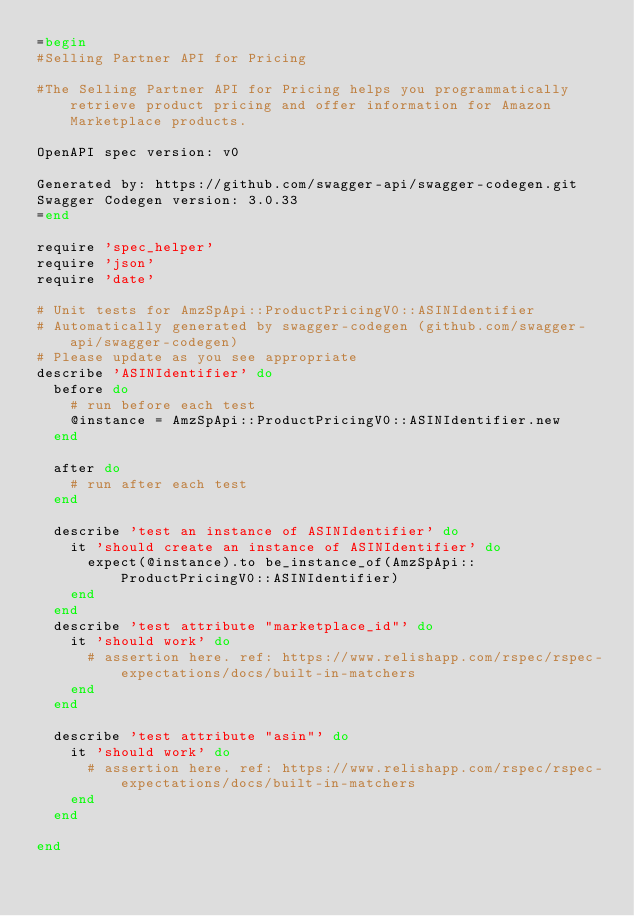<code> <loc_0><loc_0><loc_500><loc_500><_Ruby_>=begin
#Selling Partner API for Pricing

#The Selling Partner API for Pricing helps you programmatically retrieve product pricing and offer information for Amazon Marketplace products.

OpenAPI spec version: v0

Generated by: https://github.com/swagger-api/swagger-codegen.git
Swagger Codegen version: 3.0.33
=end

require 'spec_helper'
require 'json'
require 'date'

# Unit tests for AmzSpApi::ProductPricingV0::ASINIdentifier
# Automatically generated by swagger-codegen (github.com/swagger-api/swagger-codegen)
# Please update as you see appropriate
describe 'ASINIdentifier' do
  before do
    # run before each test
    @instance = AmzSpApi::ProductPricingV0::ASINIdentifier.new
  end

  after do
    # run after each test
  end

  describe 'test an instance of ASINIdentifier' do
    it 'should create an instance of ASINIdentifier' do
      expect(@instance).to be_instance_of(AmzSpApi::ProductPricingV0::ASINIdentifier)
    end
  end
  describe 'test attribute "marketplace_id"' do
    it 'should work' do
      # assertion here. ref: https://www.relishapp.com/rspec/rspec-expectations/docs/built-in-matchers
    end
  end

  describe 'test attribute "asin"' do
    it 'should work' do
      # assertion here. ref: https://www.relishapp.com/rspec/rspec-expectations/docs/built-in-matchers
    end
  end

end
</code> 